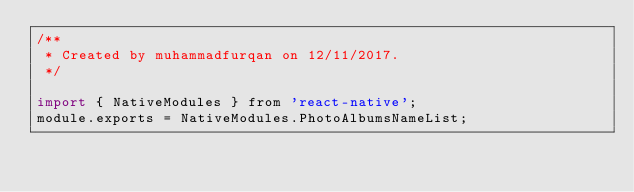Convert code to text. <code><loc_0><loc_0><loc_500><loc_500><_JavaScript_>/**
 * Created by muhammadfurqan on 12/11/2017.
 */

import { NativeModules } from 'react-native';
module.exports = NativeModules.PhotoAlbumsNameList;</code> 